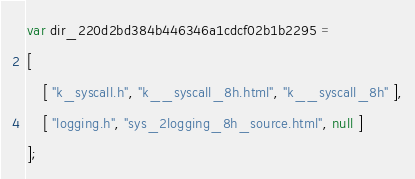Convert code to text. <code><loc_0><loc_0><loc_500><loc_500><_JavaScript_>var dir_220d2bd384b446346a1cdcf02b1b2295 =
[
    [ "k_syscall.h", "k__syscall_8h.html", "k__syscall_8h" ],
    [ "logging.h", "sys_2logging_8h_source.html", null ]
];</code> 